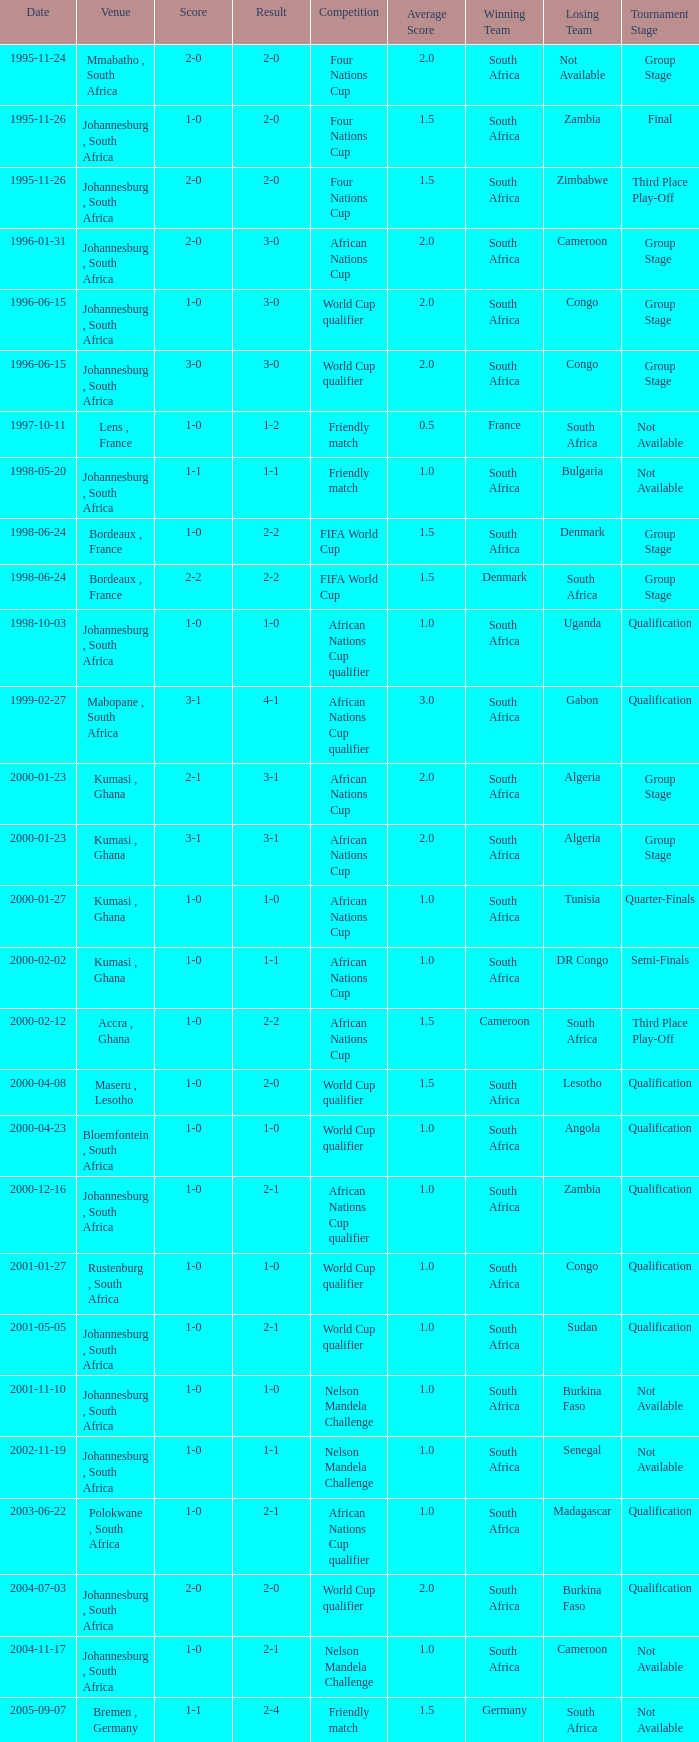What is the Date of the Fifa World Cup with a Score of 1-0? 1998-06-24. 